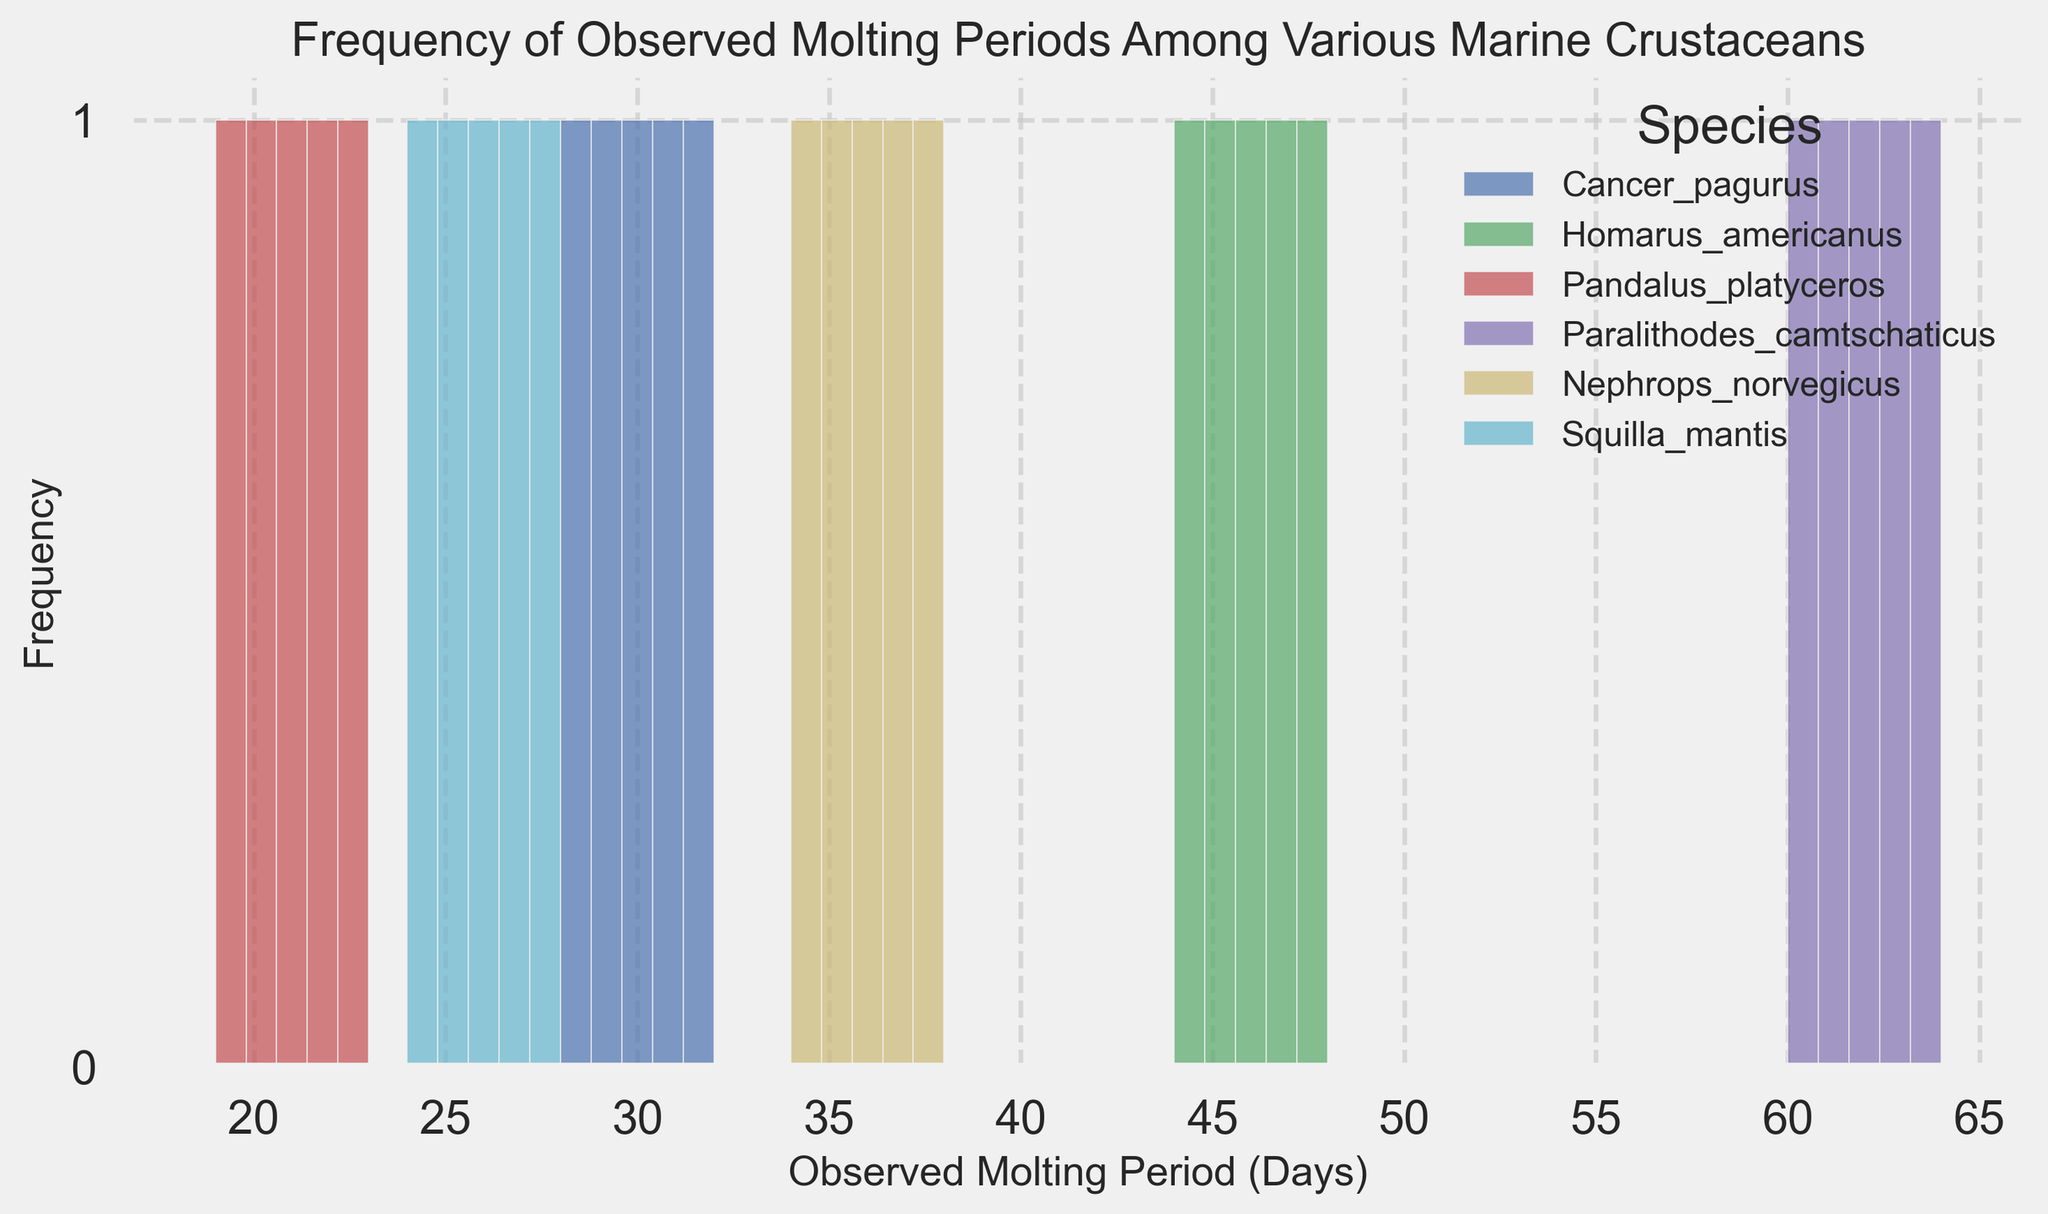Which species has the highest frequency of observed molting periods around 30 days? By observing the histogram, we can see that Cancer_pagurus has the highest frequency of molting periods around 30 days with several data points clustered around 28 to 32 days.
Answer: Cancer_pagurus Which species exhibits the widest range of molting periods? Paralithodes_camtschaticus has observed molting periods ranging from 60 to 64 days, indicating a wide range of 4 days.
Answer: Paralithodes_camtschaticus What is the approximate average molting period for Nephrops_norvegicus? Nephrops_norvegicus has molting periods of 34, 35, 36, 37, and 38 days. Adding these values and dividing by 5 gives (34 + 35 + 36 + 37 + 38) / 5 = 36.
Answer: 36 How does the molting period range of Squilla_mantis compare to that of Pandalus_platyceros? Squilla_mantis has a molting period range from 24 to 28 days (4 days) while Pandalus_platyceros has a molting period range from 19 to 23 days (4 days). Both species have the same range of molting periods.
Answer: Equal For which species does the histogram show the least variability in molting periods? The histogram shows Homarus_americanus has data points closely clustered between 44 to 48 days, indicating the least variability (4 days) compared to other species.
Answer: Homarus_americanus How does the peak frequency of observed molting periods for Cancer_pagurus compare to that of Squilla_mantis? Both Cancer_pagurus and Squilla_mantis have peak frequencies that are visually similar, indicating similar numbers of observations at their most frequent molting periods.
Answer: Similar Which species has the most evenly distributed molting period frequencies? Nephrops_norvegicus shows an even distribution of frequencies across its molting periods from 34 to 38 days.
Answer: Nephrops_norvegicus 